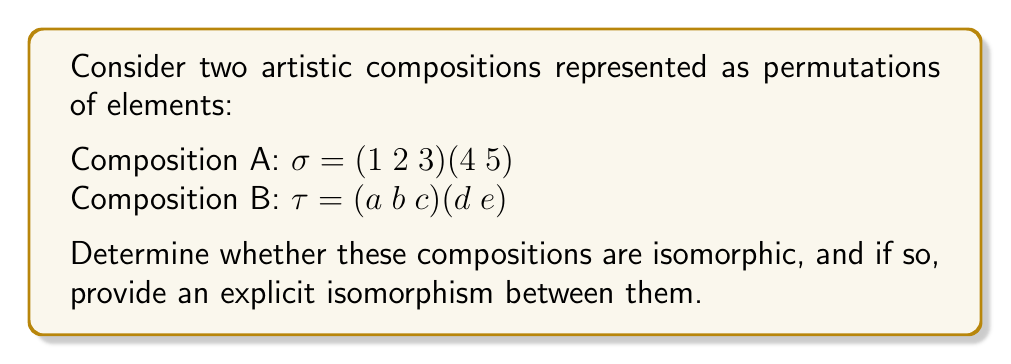Help me with this question. To determine if the compositions are isomorphic, we need to analyze their group structure:

1. Both compositions are represented as permutations.
2. Composition A ($\sigma$) consists of a 3-cycle and a 2-cycle.
3. Composition B ($\tau$) also consists of a 3-cycle and a 2-cycle.

To prove isomorphism, we need to show that there exists a bijective function $f$ that preserves the group operation. In this case, we can construct an isomorphism as follows:

$f: \{1, 2, 3, 4, 5\} \rightarrow \{a, b, c, d, e\}$

Define $f$ as:
$f(1) = a$
$f(2) = b$
$f(3) = c$
$f(4) = d$
$f(5) = e$

Now, we need to verify that $f$ preserves the group operation:

$f(\sigma(1)) = f(2) = b = \tau(a) = \tau(f(1))$
$f(\sigma(2)) = f(3) = c = \tau(b) = \tau(f(2))$
$f(\sigma(3)) = f(1) = a = \tau(c) = \tau(f(3))$
$f(\sigma(4)) = f(5) = e = \tau(d) = \tau(f(4))$
$f(\sigma(5)) = f(4) = d = \tau(e) = \tau(f(5))$

Since $f$ is bijective and preserves the group operation, it is an isomorphism between the two compositions.

In the context of artistic compositions, this isomorphism shows that these two representations have the same underlying structure. An artist could use this knowledge to transform one composition into another while preserving its essential relationships and proportions.
Answer: Yes, the compositions are isomorphic. An explicit isomorphism is given by the function $f: \{1, 2, 3, 4, 5\} \rightarrow \{a, b, c, d, e\}$ where $f(1) = a$, $f(2) = b$, $f(3) = c$, $f(4) = d$, and $f(5) = e$. 